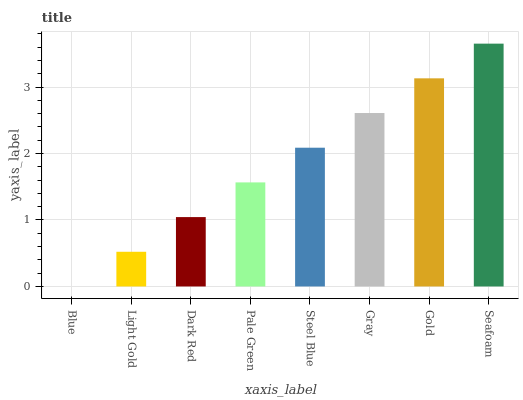Is Blue the minimum?
Answer yes or no. Yes. Is Seafoam the maximum?
Answer yes or no. Yes. Is Light Gold the minimum?
Answer yes or no. No. Is Light Gold the maximum?
Answer yes or no. No. Is Light Gold greater than Blue?
Answer yes or no. Yes. Is Blue less than Light Gold?
Answer yes or no. Yes. Is Blue greater than Light Gold?
Answer yes or no. No. Is Light Gold less than Blue?
Answer yes or no. No. Is Steel Blue the high median?
Answer yes or no. Yes. Is Pale Green the low median?
Answer yes or no. Yes. Is Seafoam the high median?
Answer yes or no. No. Is Gold the low median?
Answer yes or no. No. 